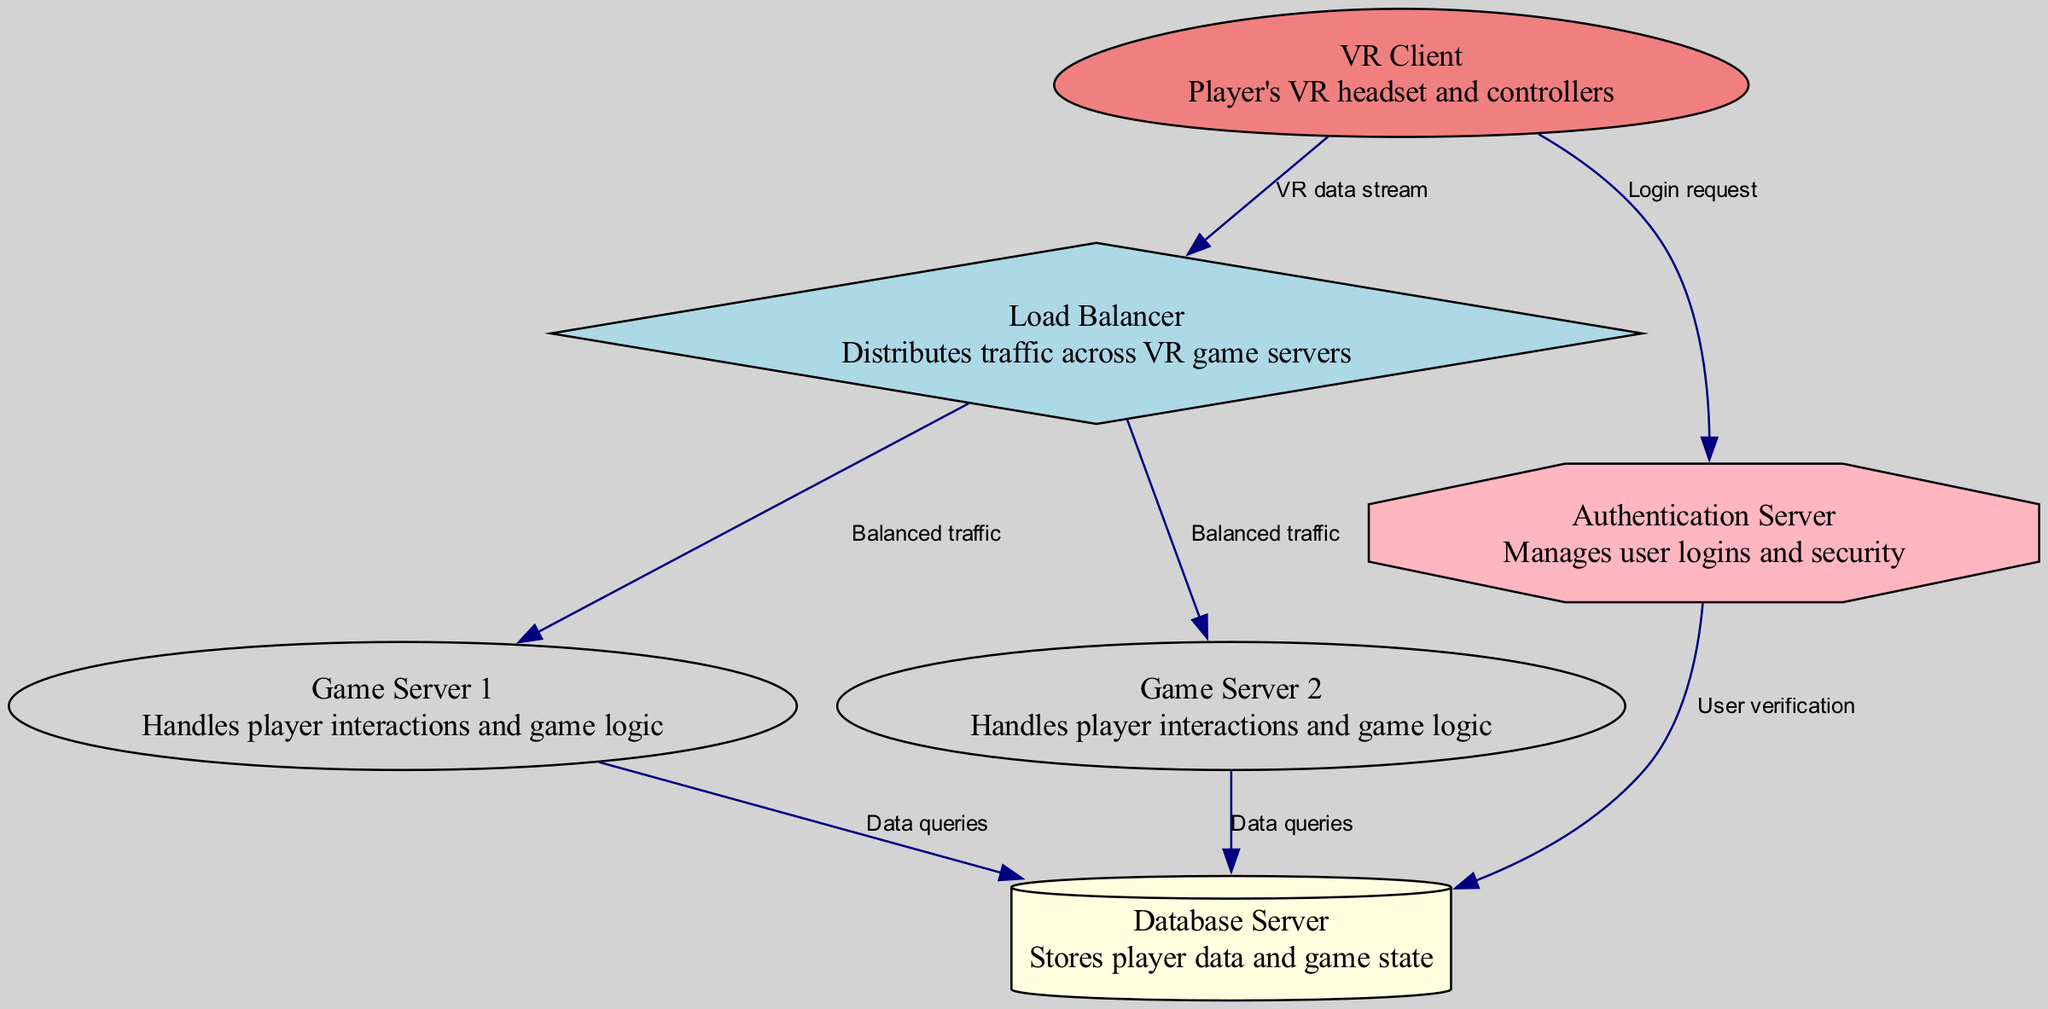What is the role of the Load Balancer? The Load Balancer is responsible for distributing traffic across VR game servers, as indicated in the description of the node labeled "Load Balancer."
Answer: Distributes traffic across VR game servers How many game servers are depicted in the diagram? The diagram shows two game servers: "Game Server 1" and "Game Server 2." Thus, counting these gives a total of two game servers.
Answer: 2 What type of connection exists between the VR Client and the Load Balancer? The edge between the VR Client and the Load Balancer is labeled "VR data stream," indicating the type of connection present between these two nodes.
Answer: VR data stream Which server manages user logins? The "Authentication Server" is labeled in the diagram as managing user logins and security, which directly answers the question about user login management.
Answer: Authentication Server What type of server is used to store player data? The "Database Server" is specifically labeled in the diagram as the server that stores player data and game state, allowing us to identify it as the correct answer.
Answer: Database Server Which nodes have connections labeled "Data queries"? Both Game Server 1 and Game Server 2 have connections to the Database Server labeled "Data queries," indicating they both query the database server for data.
Answer: Game Server 1, Game Server 2 How many connections does the Load Balancer have? The Load Balancer has two connections, one to Game Server 1 and one to Game Server 2, both labeled "Balanced traffic." Thus, we can determine that the Load Balancer has two outgoing connections.
Answer: 2 What is the direction of data flow from the Authentication Server? The Authentication Server has an outgoing connection to the Database Server, labeled "User verification," indicating the flow of data from the Authentication Server to the Database Server.
Answer: User verification Which node is labeled as the VR Client in the diagram? The node labeled "VR Client" specifically refers to "Player's VR headset and controllers," making it easy to identify which node represents the VR Client.
Answer: VR Client 